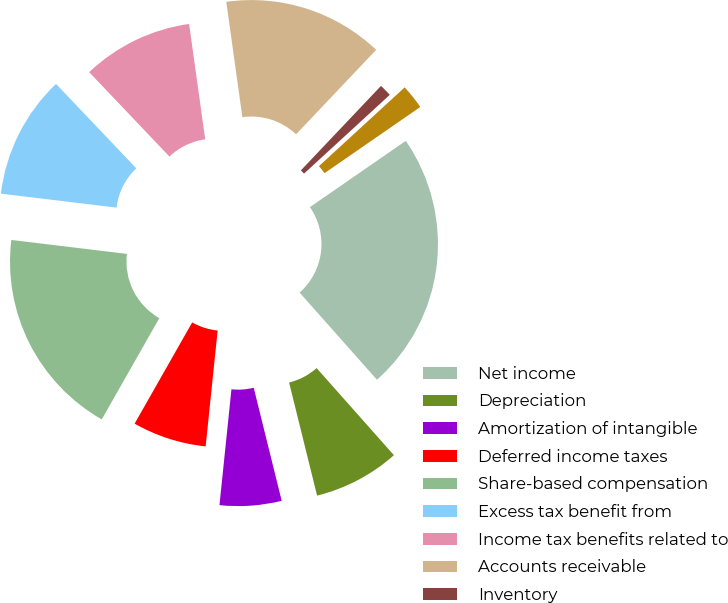<chart> <loc_0><loc_0><loc_500><loc_500><pie_chart><fcel>Net income<fcel>Depreciation<fcel>Amortization of intangible<fcel>Deferred income taxes<fcel>Share-based compensation<fcel>Excess tax benefit from<fcel>Income tax benefits related to<fcel>Accounts receivable<fcel>Inventory<fcel>Prepaids and other assets<nl><fcel>23.07%<fcel>7.69%<fcel>5.5%<fcel>6.59%<fcel>18.68%<fcel>10.99%<fcel>9.89%<fcel>14.28%<fcel>1.1%<fcel>2.2%<nl></chart> 